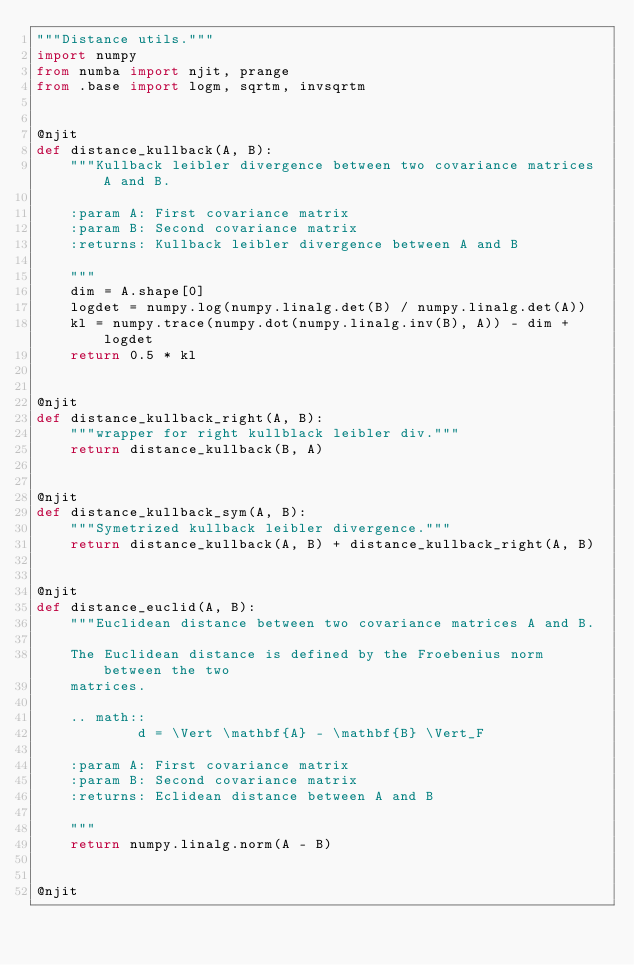Convert code to text. <code><loc_0><loc_0><loc_500><loc_500><_Python_>"""Distance utils."""
import numpy
from numba import njit, prange
from .base import logm, sqrtm, invsqrtm


@njit
def distance_kullback(A, B):
    """Kullback leibler divergence between two covariance matrices A and B.

    :param A: First covariance matrix
    :param B: Second covariance matrix
    :returns: Kullback leibler divergence between A and B

    """
    dim = A.shape[0]
    logdet = numpy.log(numpy.linalg.det(B) / numpy.linalg.det(A))
    kl = numpy.trace(numpy.dot(numpy.linalg.inv(B), A)) - dim + logdet
    return 0.5 * kl


@njit
def distance_kullback_right(A, B):
    """wrapper for right kullblack leibler div."""
    return distance_kullback(B, A)


@njit
def distance_kullback_sym(A, B):
    """Symetrized kullback leibler divergence."""
    return distance_kullback(A, B) + distance_kullback_right(A, B)


@njit
def distance_euclid(A, B):
    """Euclidean distance between two covariance matrices A and B.

    The Euclidean distance is defined by the Froebenius norm between the two
    matrices.

    .. math::
            d = \Vert \mathbf{A} - \mathbf{B} \Vert_F

    :param A: First covariance matrix
    :param B: Second covariance matrix
    :returns: Eclidean distance between A and B

    """
    return numpy.linalg.norm(A - B)


@njit</code> 